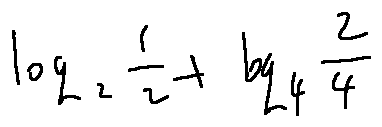Convert formula to latex. <formula><loc_0><loc_0><loc_500><loc_500>\log _ { 2 } \frac { 1 } { 2 } + \log _ { 4 } \frac { 2 } { 4 }</formula> 